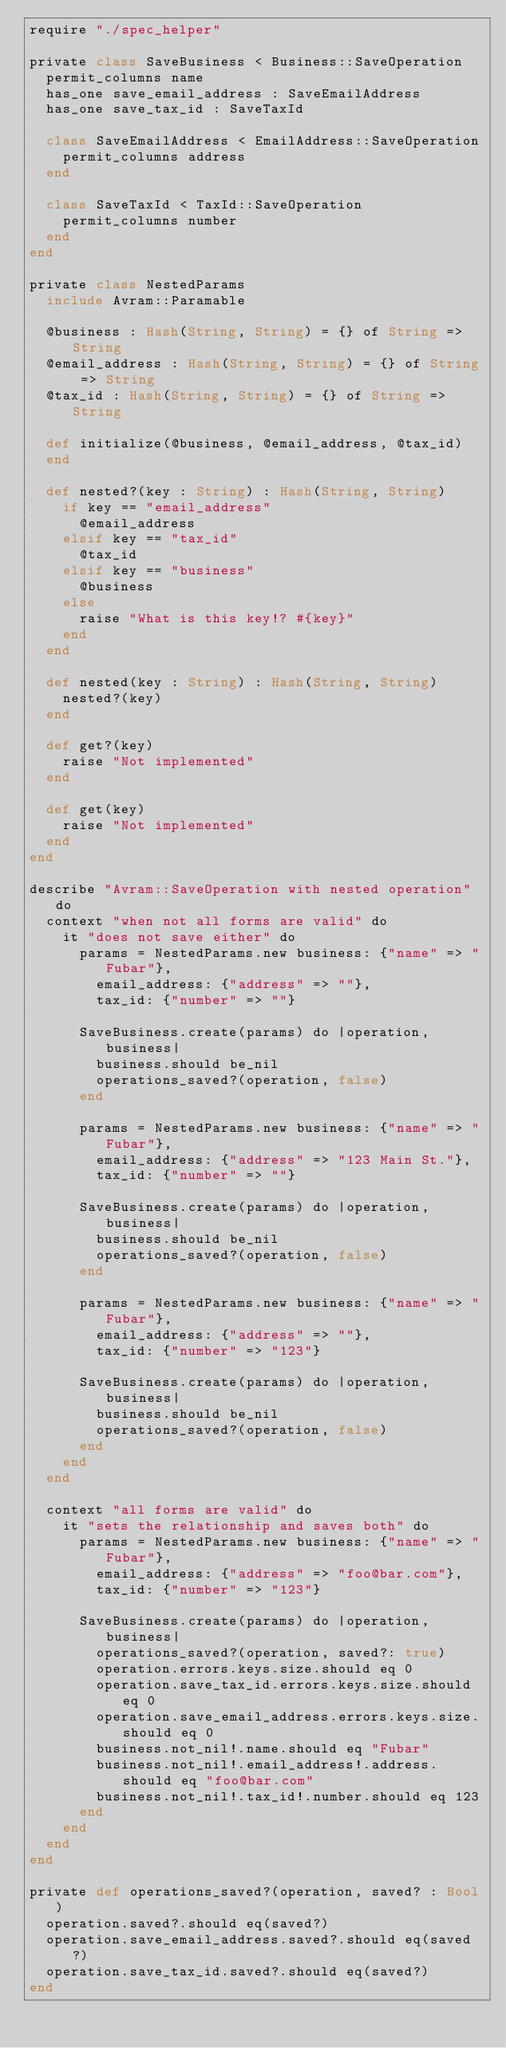Convert code to text. <code><loc_0><loc_0><loc_500><loc_500><_Crystal_>require "./spec_helper"

private class SaveBusiness < Business::SaveOperation
  permit_columns name
  has_one save_email_address : SaveEmailAddress
  has_one save_tax_id : SaveTaxId

  class SaveEmailAddress < EmailAddress::SaveOperation
    permit_columns address
  end

  class SaveTaxId < TaxId::SaveOperation
    permit_columns number
  end
end

private class NestedParams
  include Avram::Paramable

  @business : Hash(String, String) = {} of String => String
  @email_address : Hash(String, String) = {} of String => String
  @tax_id : Hash(String, String) = {} of String => String

  def initialize(@business, @email_address, @tax_id)
  end

  def nested?(key : String) : Hash(String, String)
    if key == "email_address"
      @email_address
    elsif key == "tax_id"
      @tax_id
    elsif key == "business"
      @business
    else
      raise "What is this key!? #{key}"
    end
  end

  def nested(key : String) : Hash(String, String)
    nested?(key)
  end

  def get?(key)
    raise "Not implemented"
  end

  def get(key)
    raise "Not implemented"
  end
end

describe "Avram::SaveOperation with nested operation" do
  context "when not all forms are valid" do
    it "does not save either" do
      params = NestedParams.new business: {"name" => "Fubar"},
        email_address: {"address" => ""},
        tax_id: {"number" => ""}

      SaveBusiness.create(params) do |operation, business|
        business.should be_nil
        operations_saved?(operation, false)
      end

      params = NestedParams.new business: {"name" => "Fubar"},
        email_address: {"address" => "123 Main St."},
        tax_id: {"number" => ""}

      SaveBusiness.create(params) do |operation, business|
        business.should be_nil
        operations_saved?(operation, false)
      end

      params = NestedParams.new business: {"name" => "Fubar"},
        email_address: {"address" => ""},
        tax_id: {"number" => "123"}

      SaveBusiness.create(params) do |operation, business|
        business.should be_nil
        operations_saved?(operation, false)
      end
    end
  end

  context "all forms are valid" do
    it "sets the relationship and saves both" do
      params = NestedParams.new business: {"name" => "Fubar"},
        email_address: {"address" => "foo@bar.com"},
        tax_id: {"number" => "123"}

      SaveBusiness.create(params) do |operation, business|
        operations_saved?(operation, saved?: true)
        operation.errors.keys.size.should eq 0
        operation.save_tax_id.errors.keys.size.should eq 0
        operation.save_email_address.errors.keys.size.should eq 0
        business.not_nil!.name.should eq "Fubar"
        business.not_nil!.email_address!.address.should eq "foo@bar.com"
        business.not_nil!.tax_id!.number.should eq 123
      end
    end
  end
end

private def operations_saved?(operation, saved? : Bool)
  operation.saved?.should eq(saved?)
  operation.save_email_address.saved?.should eq(saved?)
  operation.save_tax_id.saved?.should eq(saved?)
end
</code> 